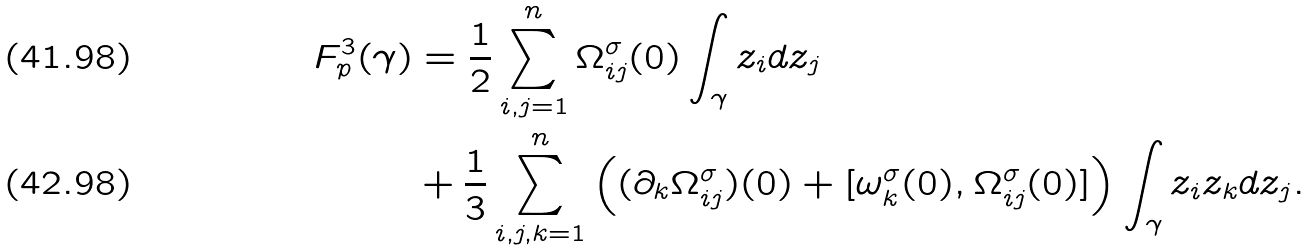<formula> <loc_0><loc_0><loc_500><loc_500>F _ { p } ^ { 3 } ( \gamma ) & = \frac { 1 } { 2 } \sum _ { i , j = 1 } ^ { n } \Omega _ { i j } ^ { \sigma } ( 0 ) \int _ { \gamma } z _ { i } d z _ { j } \\ & + \frac { 1 } { 3 } \sum _ { i , j , k = 1 } ^ { n } \left ( ( \partial _ { k } \Omega _ { i j } ^ { \sigma } ) ( 0 ) + [ \omega _ { k } ^ { \sigma } ( 0 ) , \Omega _ { i j } ^ { \sigma } ( 0 ) ] \right ) \int _ { \gamma } z _ { i } z _ { k } d z _ { j } .</formula> 